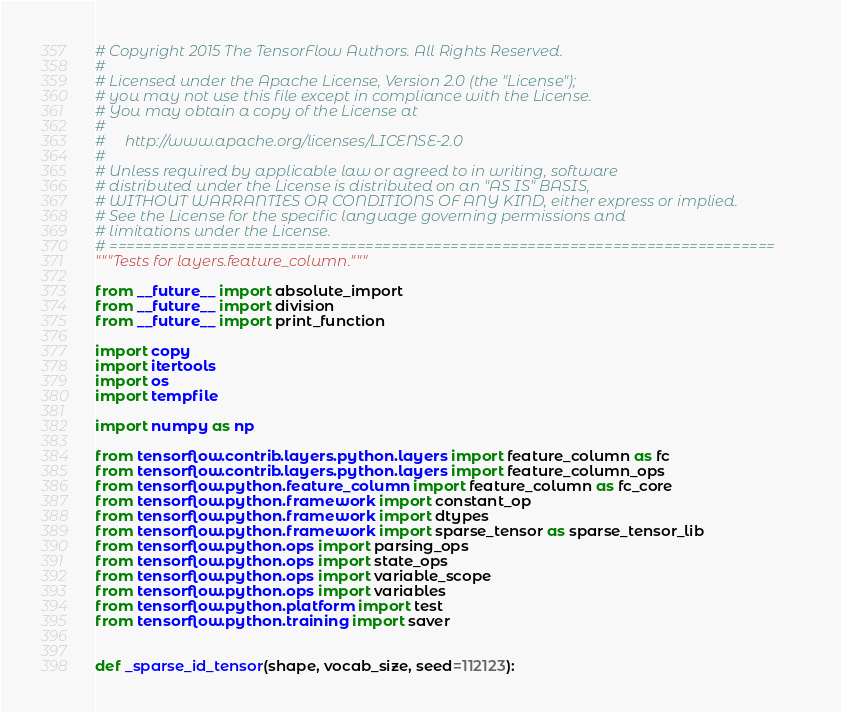<code> <loc_0><loc_0><loc_500><loc_500><_Python_># Copyright 2015 The TensorFlow Authors. All Rights Reserved.
#
# Licensed under the Apache License, Version 2.0 (the "License");
# you may not use this file except in compliance with the License.
# You may obtain a copy of the License at
#
#     http://www.apache.org/licenses/LICENSE-2.0
#
# Unless required by applicable law or agreed to in writing, software
# distributed under the License is distributed on an "AS IS" BASIS,
# WITHOUT WARRANTIES OR CONDITIONS OF ANY KIND, either express or implied.
# See the License for the specific language governing permissions and
# limitations under the License.
# ==============================================================================
"""Tests for layers.feature_column."""

from __future__ import absolute_import
from __future__ import division
from __future__ import print_function

import copy
import itertools
import os
import tempfile

import numpy as np

from tensorflow.contrib.layers.python.layers import feature_column as fc
from tensorflow.contrib.layers.python.layers import feature_column_ops
from tensorflow.python.feature_column import feature_column as fc_core
from tensorflow.python.framework import constant_op
from tensorflow.python.framework import dtypes
from tensorflow.python.framework import sparse_tensor as sparse_tensor_lib
from tensorflow.python.ops import parsing_ops
from tensorflow.python.ops import state_ops
from tensorflow.python.ops import variable_scope
from tensorflow.python.ops import variables
from tensorflow.python.platform import test
from tensorflow.python.training import saver


def _sparse_id_tensor(shape, vocab_size, seed=112123):</code> 